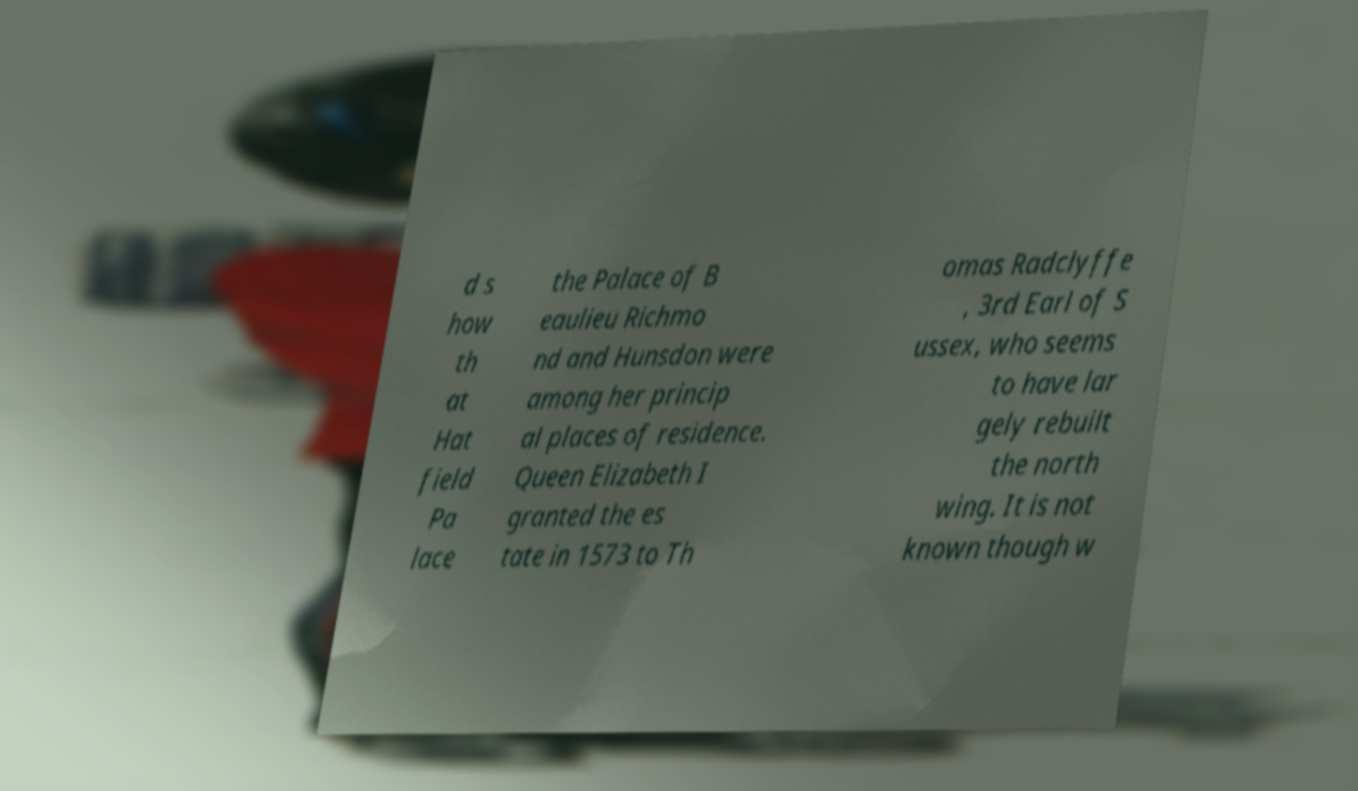Can you accurately transcribe the text from the provided image for me? d s how th at Hat field Pa lace the Palace of B eaulieu Richmo nd and Hunsdon were among her princip al places of residence. Queen Elizabeth I granted the es tate in 1573 to Th omas Radclyffe , 3rd Earl of S ussex, who seems to have lar gely rebuilt the north wing. It is not known though w 